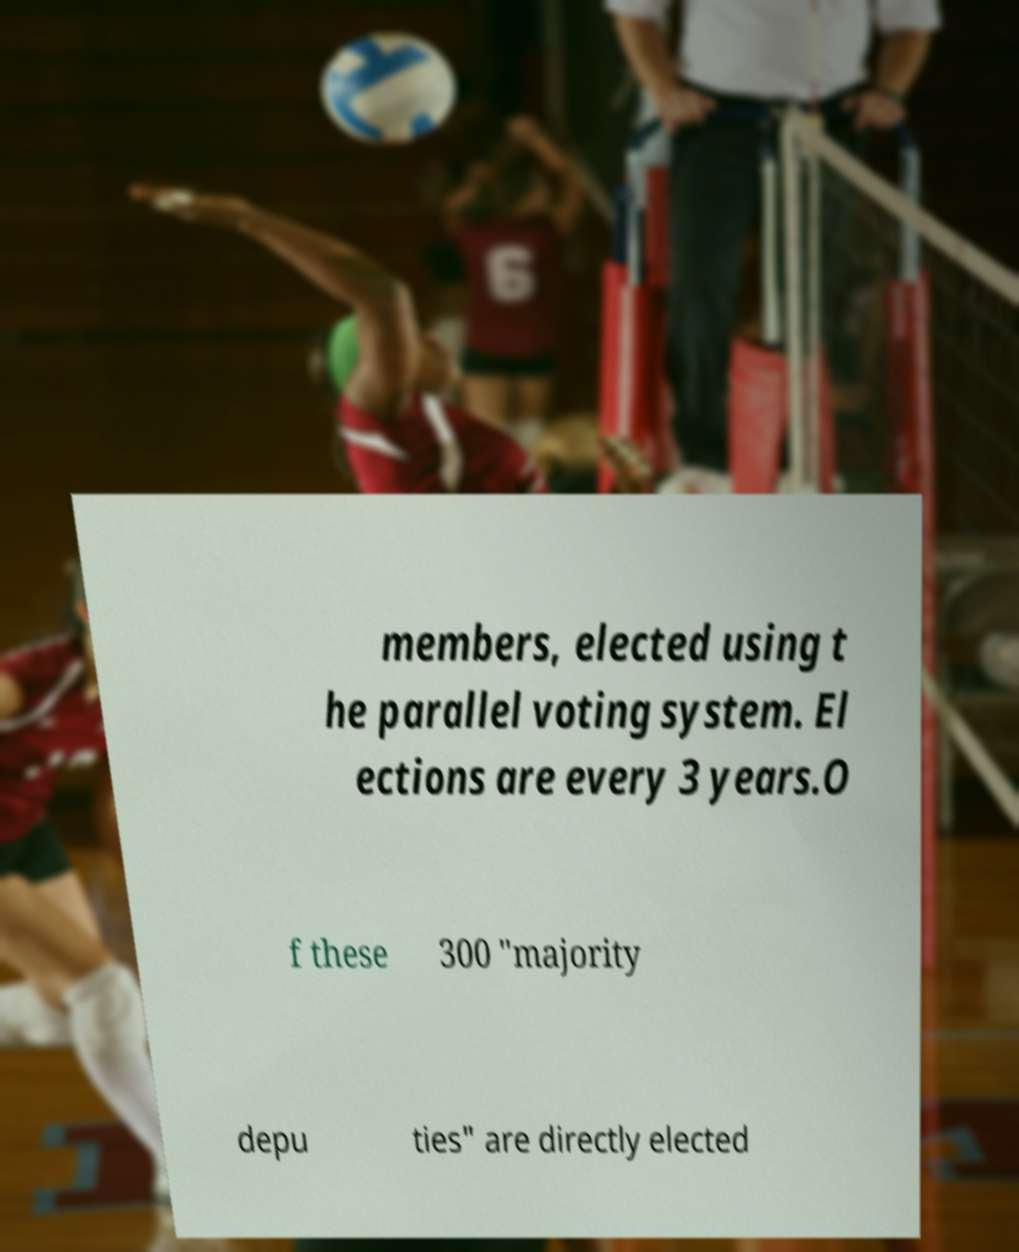Can you read and provide the text displayed in the image?This photo seems to have some interesting text. Can you extract and type it out for me? members, elected using t he parallel voting system. El ections are every 3 years.O f these 300 "majority depu ties" are directly elected 